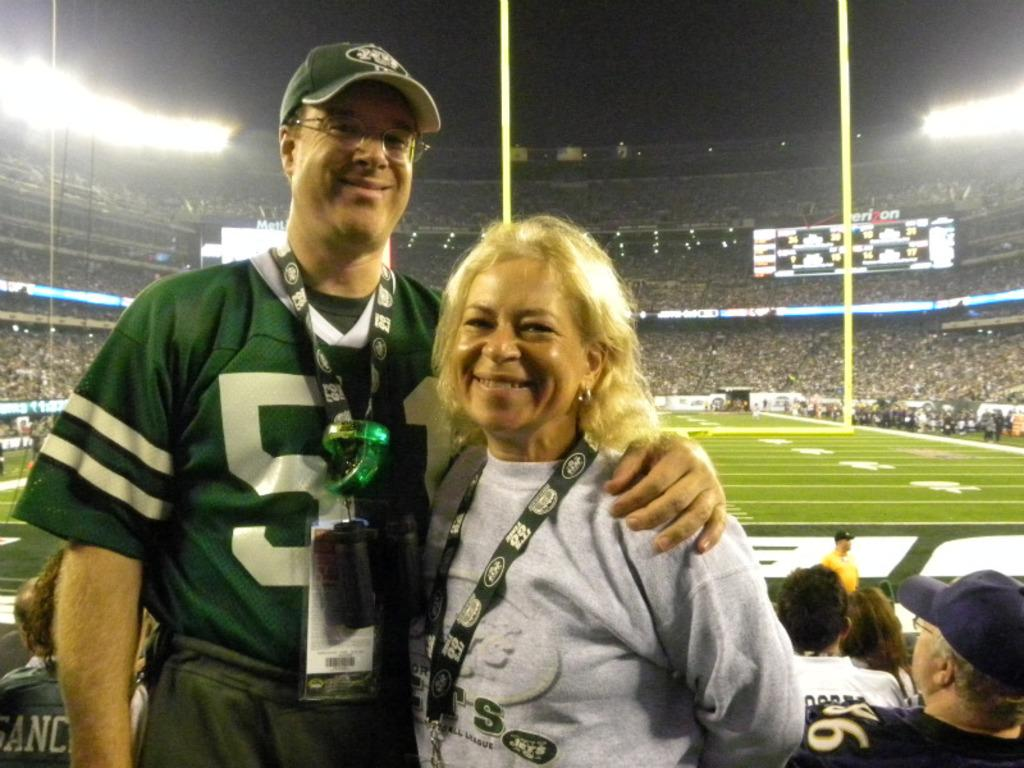How many people are present in the image? There are two people standing in the image. What is the facial expression of the people in the image? The people are smiling. What type of surface can be seen at the bottom of the image? There is ground visible in the image. What can be seen in the background of the image? There are poles, screens, lights, and a group of people in the background of the image. How would you describe the lighting conditions in the background of the image? The background of the image is dark. Can you see a curtain being used by the people in the image? There is no curtain present in the image. How high can the people in the image jump? The image does not show the people jumping, so it is not possible to determine their jumping ability. 